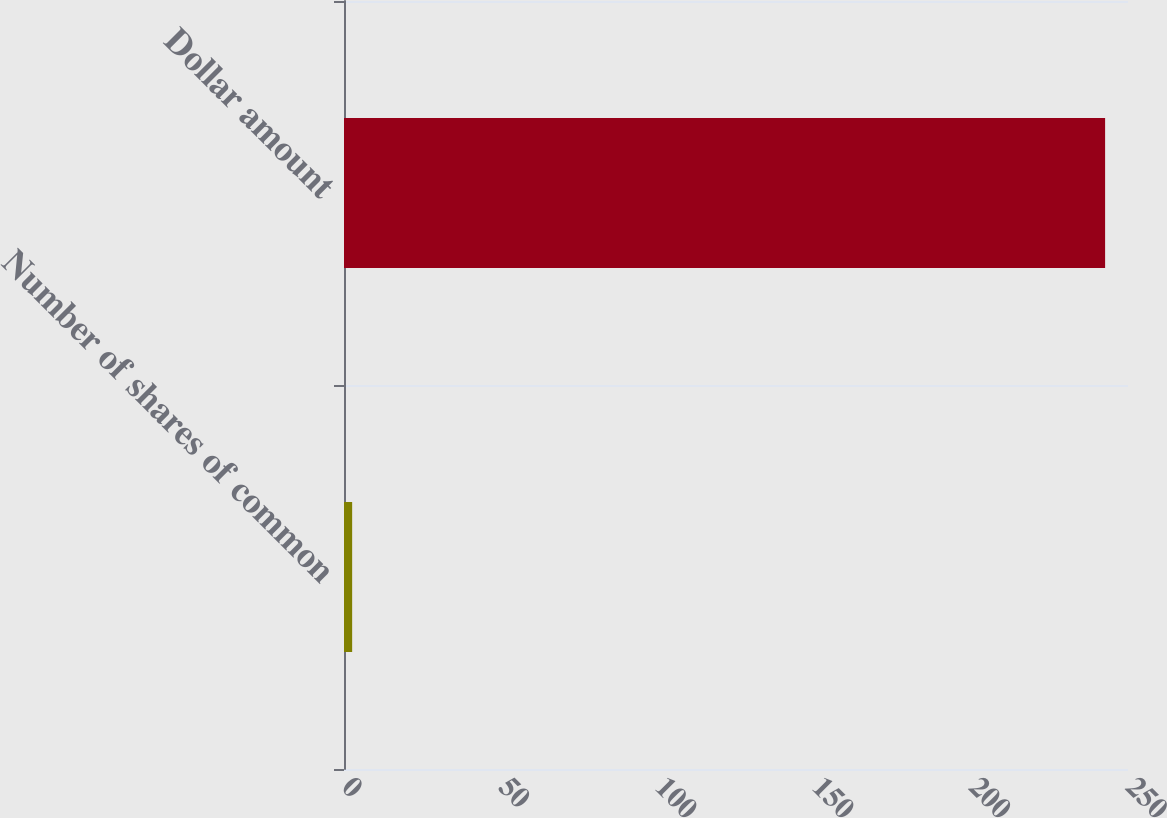Convert chart to OTSL. <chart><loc_0><loc_0><loc_500><loc_500><bar_chart><fcel>Number of shares of common<fcel>Dollar amount<nl><fcel>2.6<fcel>242.7<nl></chart> 